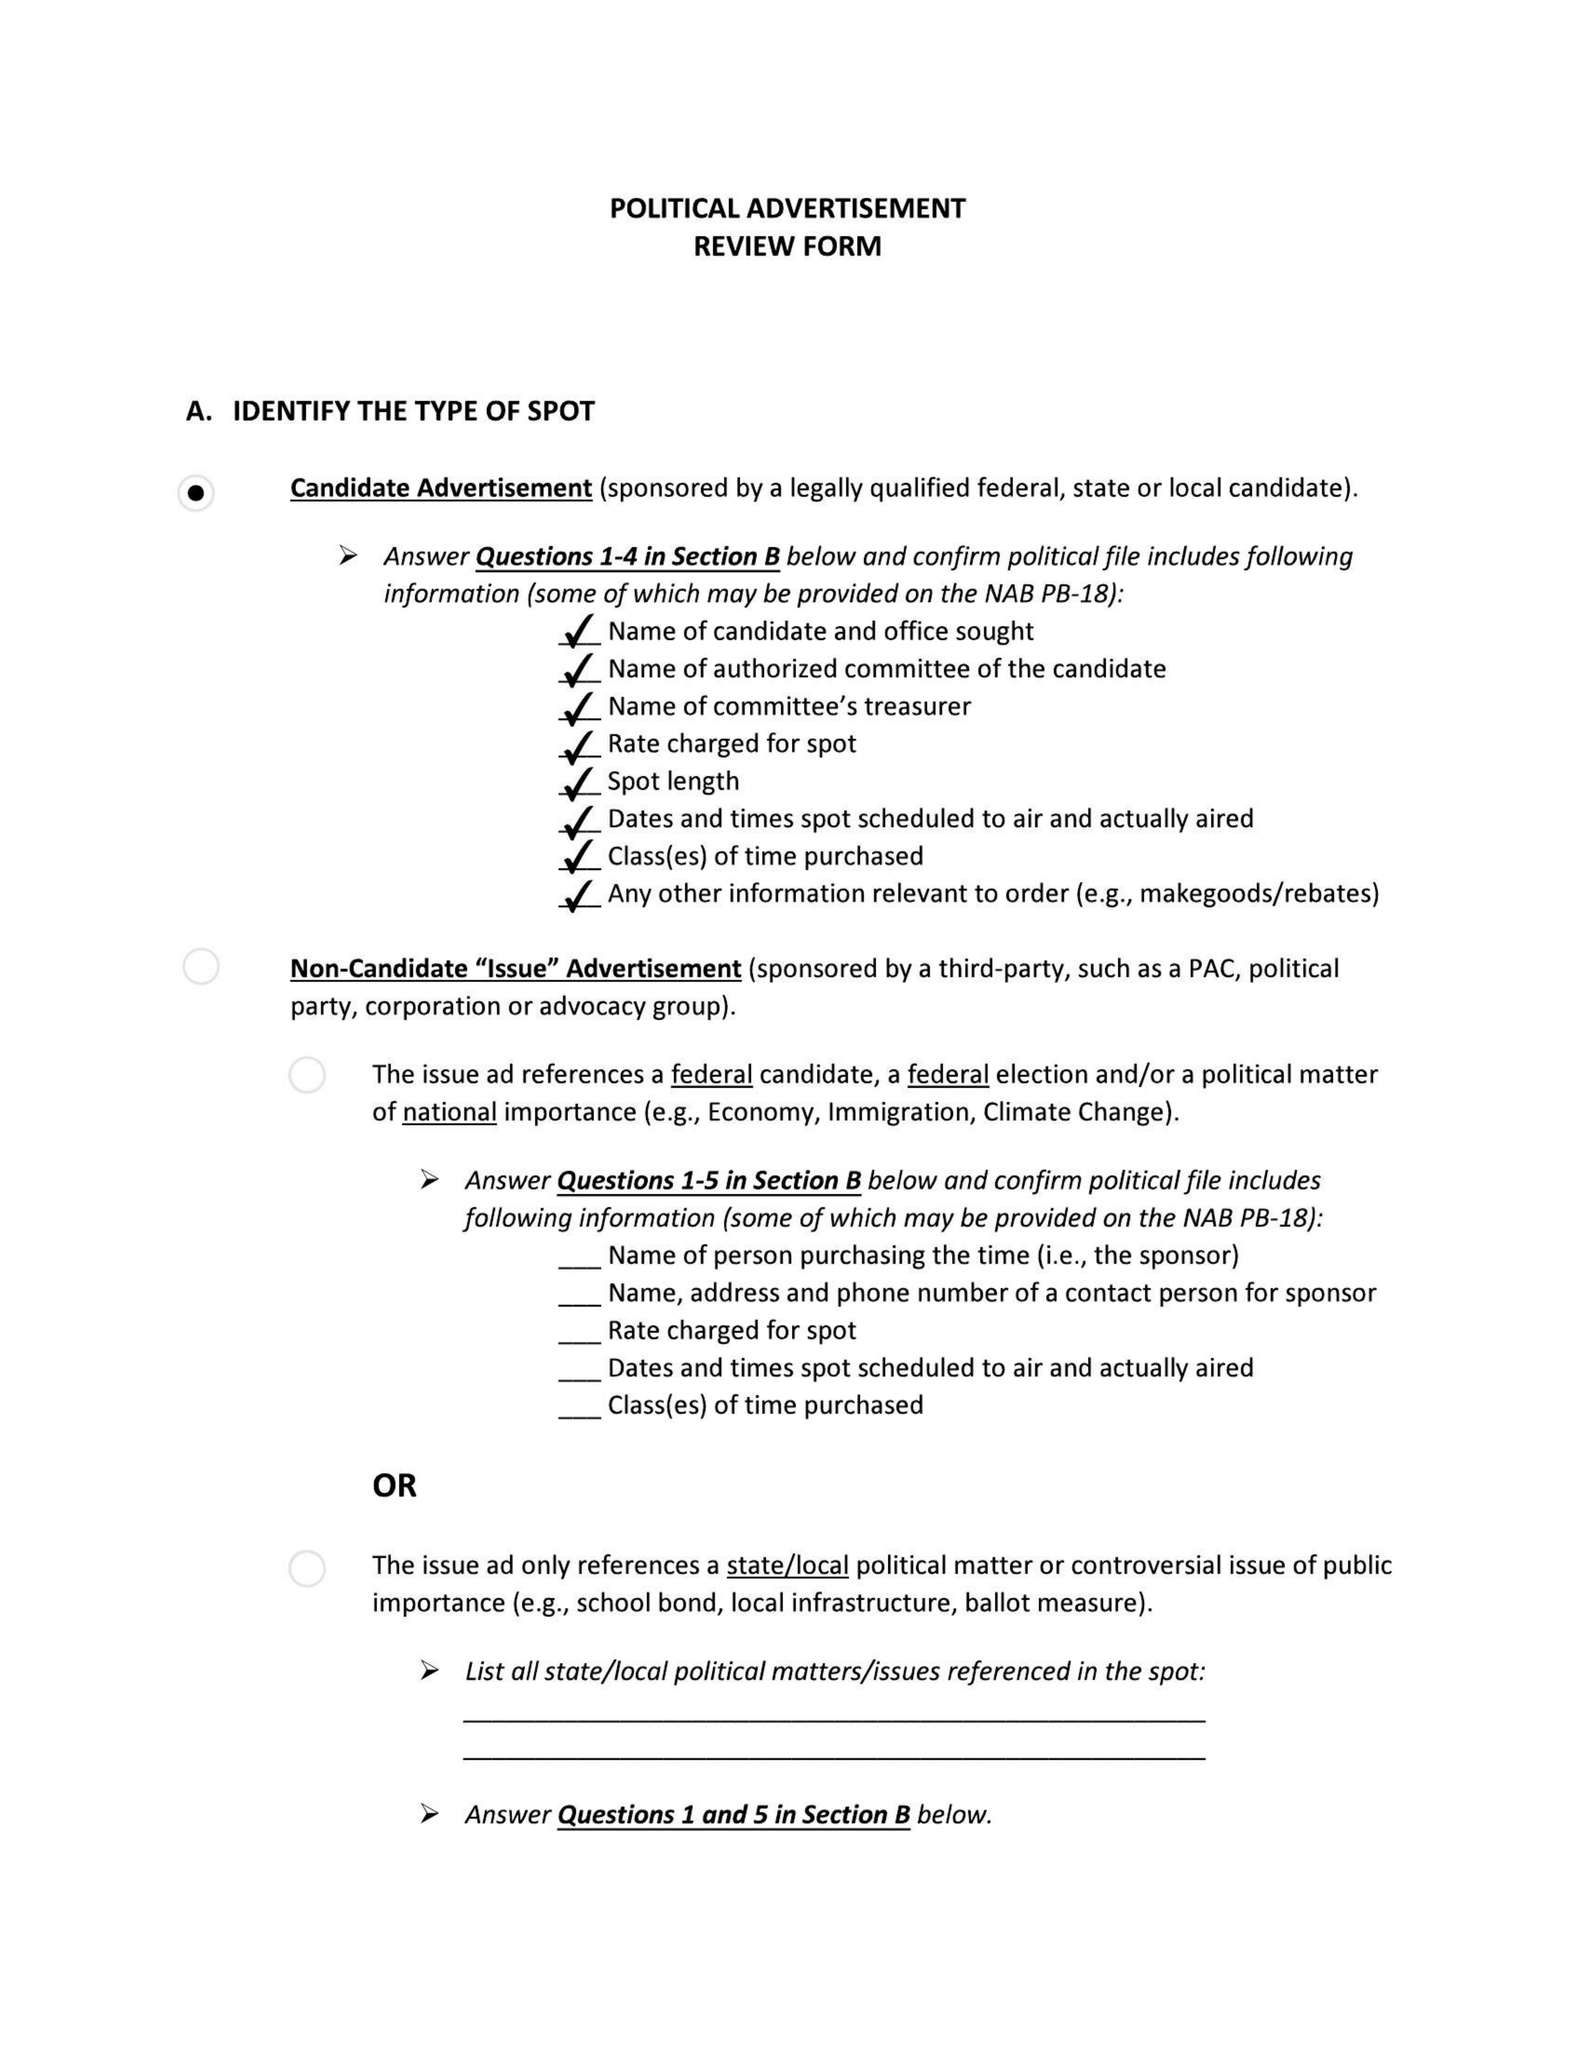What is the value for the flight_from?
Answer the question using a single word or phrase. None 